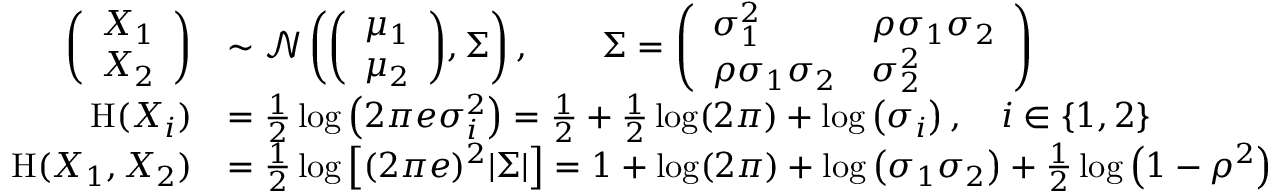<formula> <loc_0><loc_0><loc_500><loc_500>{ \begin{array} { r l } { { \left ( \begin{array} { l } { X _ { 1 } } \\ { X _ { 2 } } \end{array} \right ) } } & { \sim { \mathcal { N } } \left ( { \left ( \begin{array} { l } { \mu _ { 1 } } \\ { \mu _ { 2 } } \end{array} \right ) } , \Sigma \right ) , \quad \Sigma = { \left ( \begin{array} { l l } { \sigma _ { 1 } ^ { 2 } } & { \rho \sigma _ { 1 } \sigma _ { 2 } } \\ { \rho \sigma _ { 1 } \sigma _ { 2 } } & { \sigma _ { 2 } ^ { 2 } } \end{array} \right ) } } \\ { H ( X _ { i } ) } & { = { \frac { 1 } { 2 } } \log \left ( 2 \pi e \sigma _ { i } ^ { 2 } \right ) = { \frac { 1 } { 2 } } + { \frac { 1 } { 2 } } \log ( 2 \pi ) + \log \left ( \sigma _ { i } \right ) , \quad i \in \{ 1 , 2 \} } \\ { H ( X _ { 1 } , X _ { 2 } ) } & { = { \frac { 1 } { 2 } } \log \left [ ( 2 \pi e ) ^ { 2 } | \Sigma | \right ] = 1 + \log ( 2 \pi ) + \log \left ( \sigma _ { 1 } \sigma _ { 2 } \right ) + { \frac { 1 } { 2 } } \log \left ( 1 - \rho ^ { 2 } \right ) } \end{array} }</formula> 